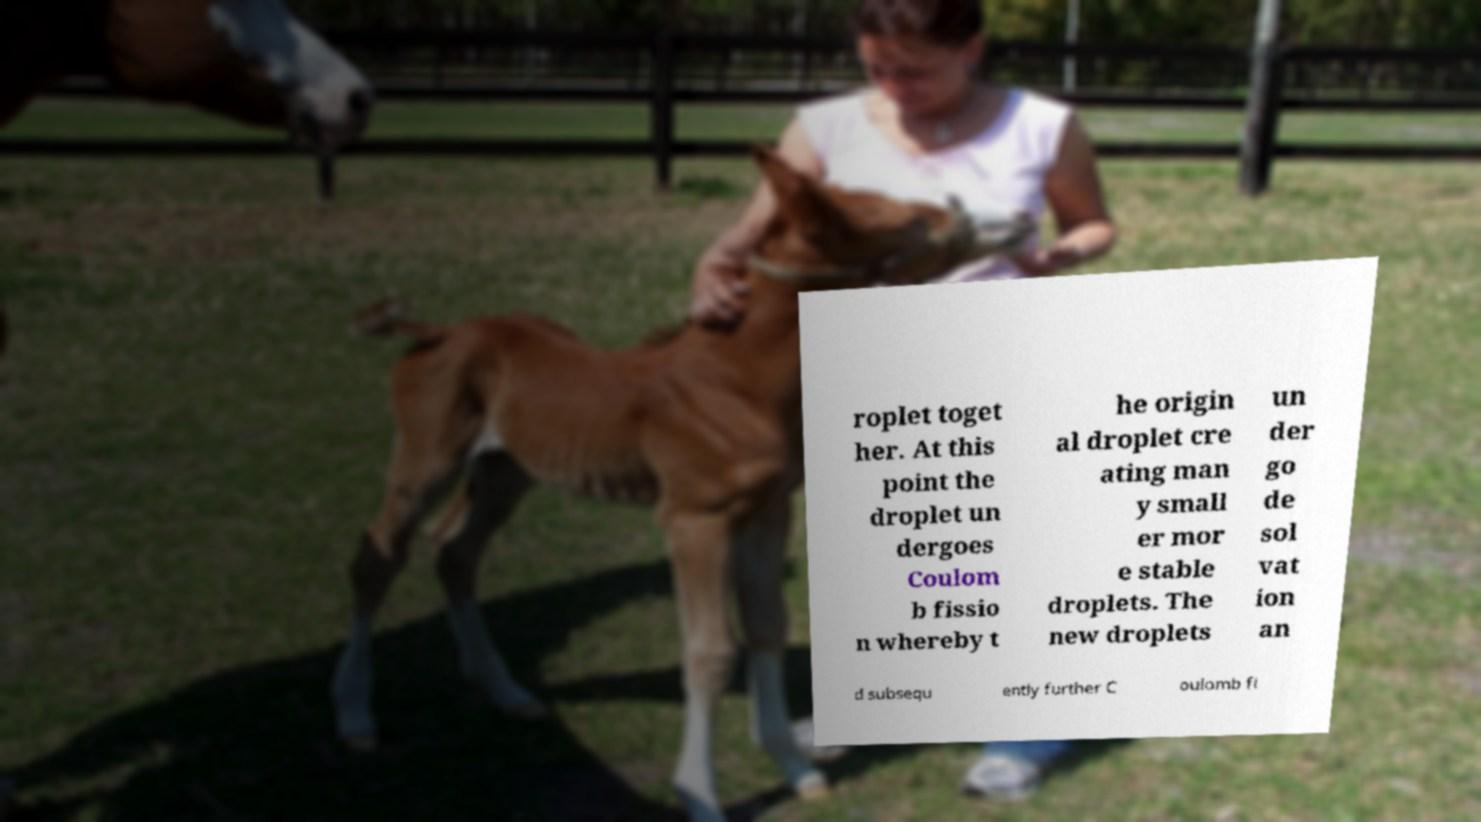What messages or text are displayed in this image? I need them in a readable, typed format. roplet toget her. At this point the droplet un dergoes Coulom b fissio n whereby t he origin al droplet cre ating man y small er mor e stable droplets. The new droplets un der go de sol vat ion an d subsequ ently further C oulomb fi 